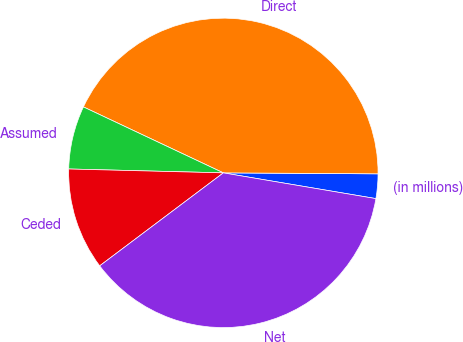<chart> <loc_0><loc_0><loc_500><loc_500><pie_chart><fcel>(in millions)<fcel>Direct<fcel>Assumed<fcel>Ceded<fcel>Net<nl><fcel>2.56%<fcel>43.09%<fcel>6.61%<fcel>10.66%<fcel>37.08%<nl></chart> 